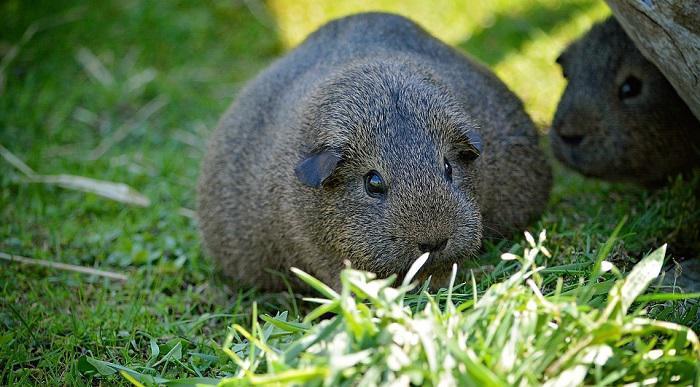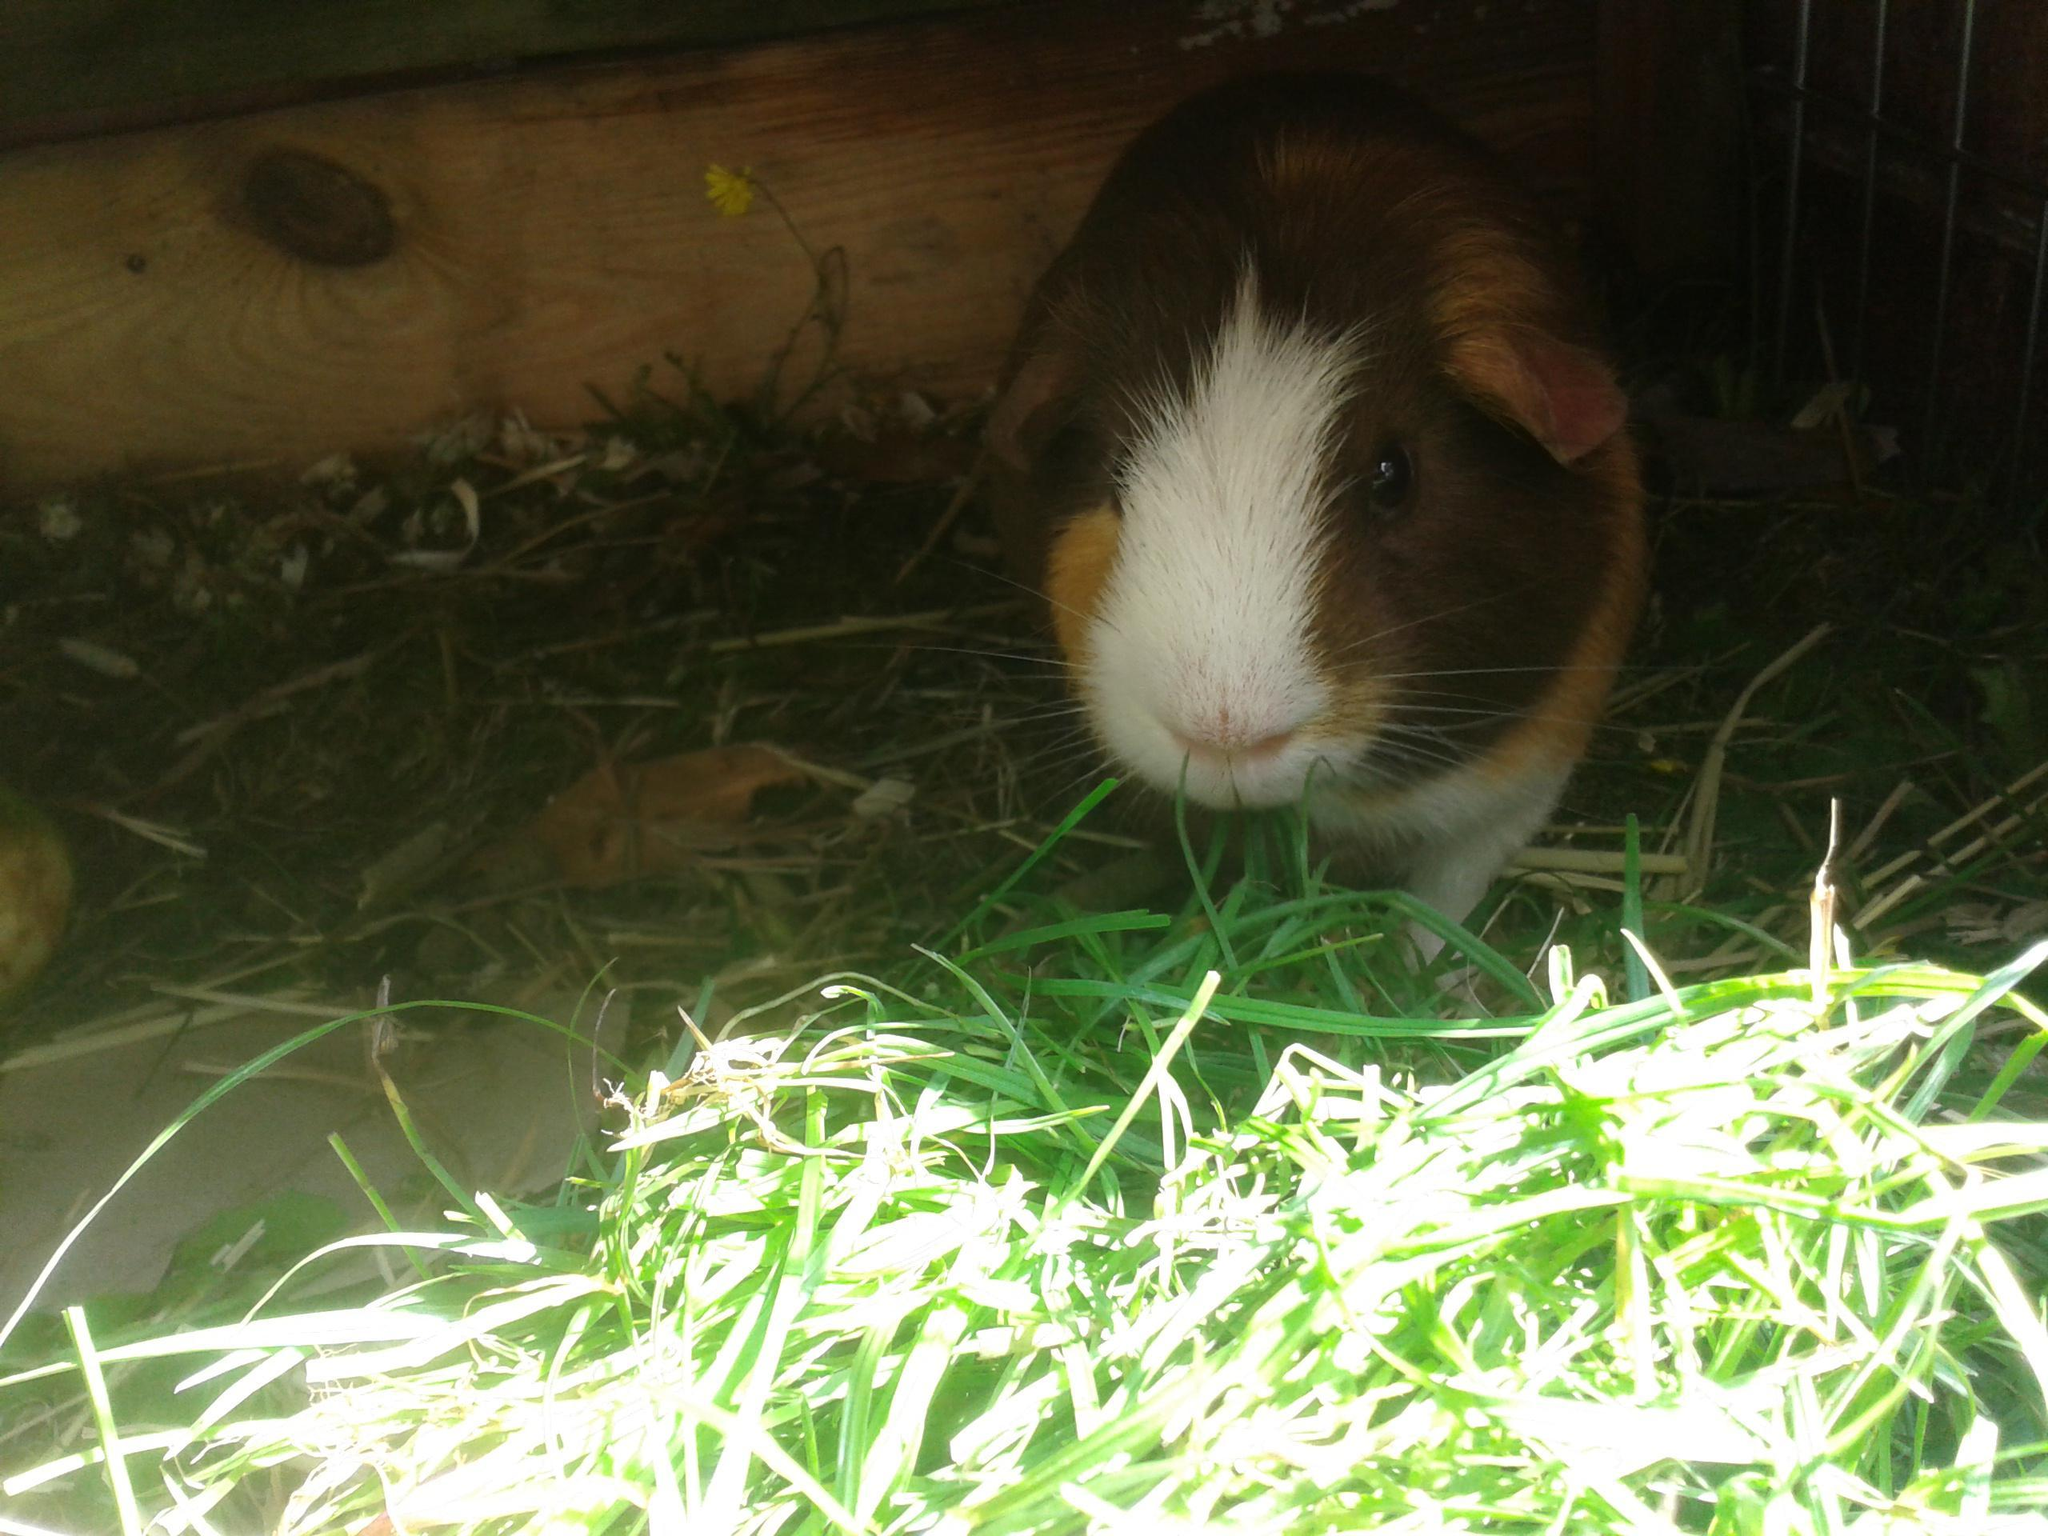The first image is the image on the left, the second image is the image on the right. Evaluate the accuracy of this statement regarding the images: "One of the images shows exactly two guinea pigs.". Is it true? Answer yes or no. Yes. The first image is the image on the left, the second image is the image on the right. For the images displayed, is the sentence "There is exactly one animal in the image on the left" factually correct? Answer yes or no. No. 